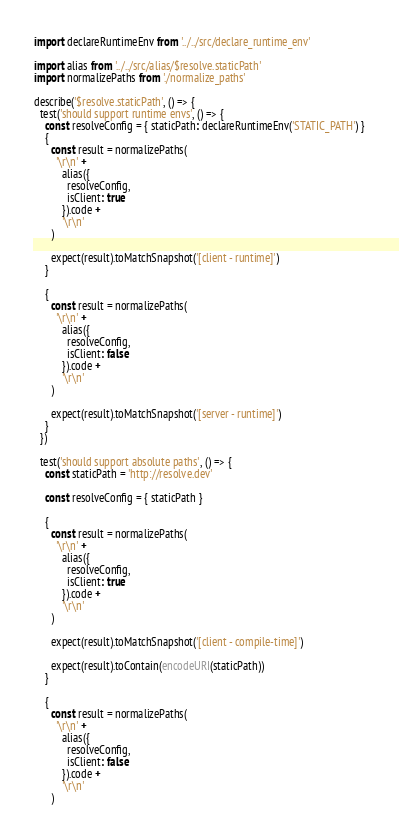Convert code to text. <code><loc_0><loc_0><loc_500><loc_500><_JavaScript_>import declareRuntimeEnv from '../../src/declare_runtime_env'

import alias from '../../src/alias/$resolve.staticPath'
import normalizePaths from './normalize_paths'

describe('$resolve.staticPath', () => {
  test('should support runtime envs', () => {
    const resolveConfig = { staticPath: declareRuntimeEnv('STATIC_PATH') }
    {
      const result = normalizePaths(
        '\r\n' +
          alias({
            resolveConfig,
            isClient: true
          }).code +
          '\r\n'
      )

      expect(result).toMatchSnapshot('[client - runtime]')
    }

    {
      const result = normalizePaths(
        '\r\n' +
          alias({
            resolveConfig,
            isClient: false
          }).code +
          '\r\n'
      )

      expect(result).toMatchSnapshot('[server - runtime]')
    }
  })

  test('should support absolute paths', () => {
    const staticPath = 'http://resolve.dev'

    const resolveConfig = { staticPath }

    {
      const result = normalizePaths(
        '\r\n' +
          alias({
            resolveConfig,
            isClient: true
          }).code +
          '\r\n'
      )

      expect(result).toMatchSnapshot('[client - compile-time]')

      expect(result).toContain(encodeURI(staticPath))
    }

    {
      const result = normalizePaths(
        '\r\n' +
          alias({
            resolveConfig,
            isClient: false
          }).code +
          '\r\n'
      )
</code> 